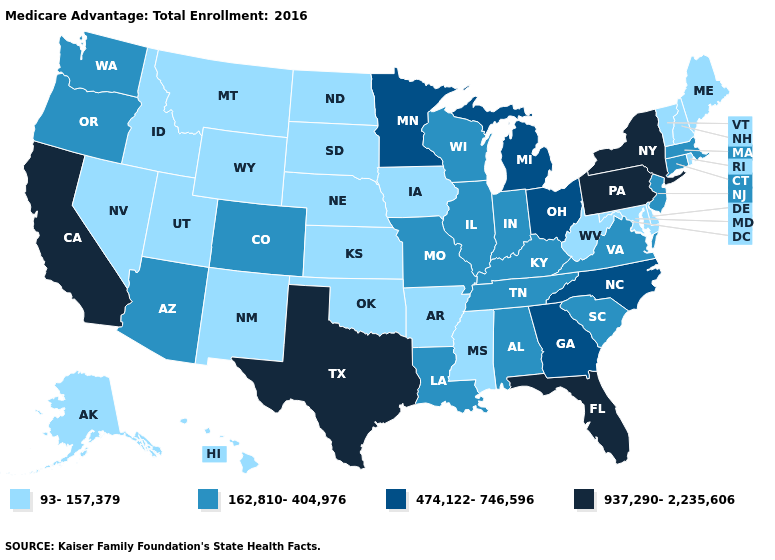Name the states that have a value in the range 937,290-2,235,606?
Write a very short answer. California, Florida, New York, Pennsylvania, Texas. Is the legend a continuous bar?
Give a very brief answer. No. Name the states that have a value in the range 93-157,379?
Answer briefly. Alaska, Arkansas, Delaware, Hawaii, Iowa, Idaho, Kansas, Maryland, Maine, Mississippi, Montana, North Dakota, Nebraska, New Hampshire, New Mexico, Nevada, Oklahoma, Rhode Island, South Dakota, Utah, Vermont, West Virginia, Wyoming. Does the map have missing data?
Give a very brief answer. No. What is the lowest value in the West?
Short answer required. 93-157,379. What is the value of Vermont?
Keep it brief. 93-157,379. Name the states that have a value in the range 162,810-404,976?
Quick response, please. Alabama, Arizona, Colorado, Connecticut, Illinois, Indiana, Kentucky, Louisiana, Massachusetts, Missouri, New Jersey, Oregon, South Carolina, Tennessee, Virginia, Washington, Wisconsin. How many symbols are there in the legend?
Give a very brief answer. 4. What is the value of Wyoming?
Write a very short answer. 93-157,379. How many symbols are there in the legend?
Be succinct. 4. Name the states that have a value in the range 162,810-404,976?
Keep it brief. Alabama, Arizona, Colorado, Connecticut, Illinois, Indiana, Kentucky, Louisiana, Massachusetts, Missouri, New Jersey, Oregon, South Carolina, Tennessee, Virginia, Washington, Wisconsin. Name the states that have a value in the range 937,290-2,235,606?
Concise answer only. California, Florida, New York, Pennsylvania, Texas. Among the states that border Oregon , which have the lowest value?
Be succinct. Idaho, Nevada. Does South Dakota have the highest value in the MidWest?
Give a very brief answer. No. What is the value of West Virginia?
Concise answer only. 93-157,379. 